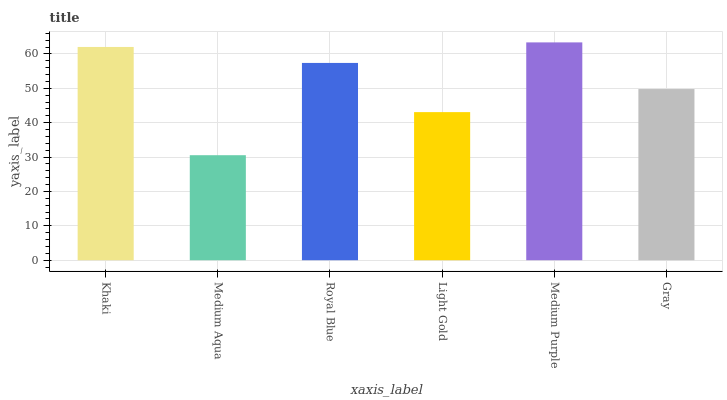Is Royal Blue the minimum?
Answer yes or no. No. Is Royal Blue the maximum?
Answer yes or no. No. Is Royal Blue greater than Medium Aqua?
Answer yes or no. Yes. Is Medium Aqua less than Royal Blue?
Answer yes or no. Yes. Is Medium Aqua greater than Royal Blue?
Answer yes or no. No. Is Royal Blue less than Medium Aqua?
Answer yes or no. No. Is Royal Blue the high median?
Answer yes or no. Yes. Is Gray the low median?
Answer yes or no. Yes. Is Medium Purple the high median?
Answer yes or no. No. Is Light Gold the low median?
Answer yes or no. No. 